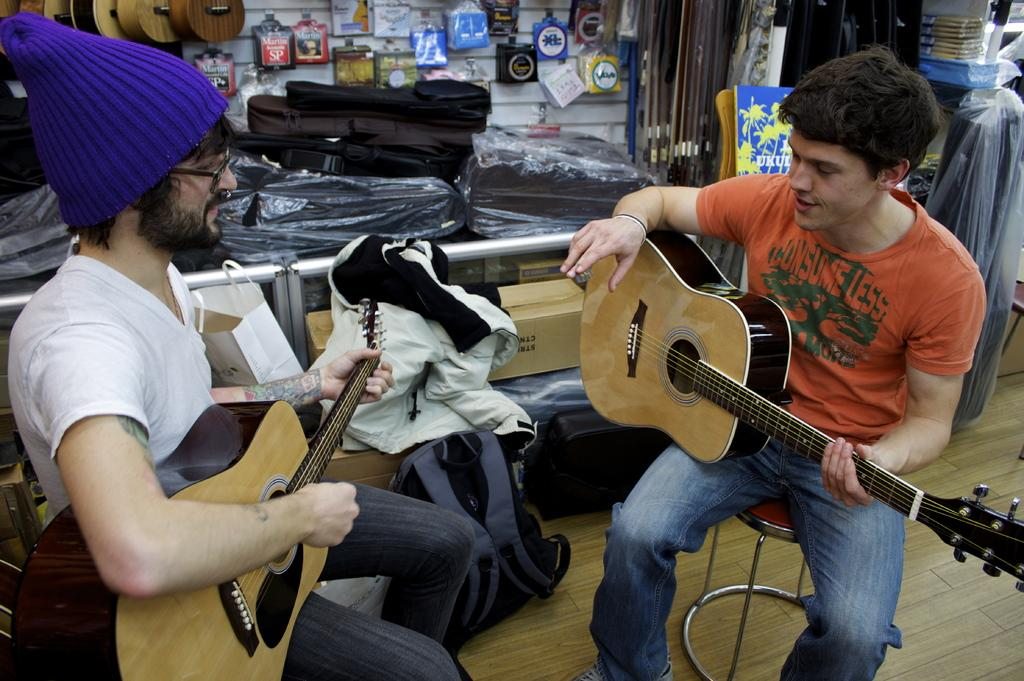How many people are in the image? There are two men in the image. What are the men doing in the image? The men are sitting on stools and playing guitars. Can you describe the objects behind the men? There are bags placed in the background behind a railing. Reasoning: Let'g: Let's think step by step in order to produce the conversation. We start by identifying the main subjects in the image, which are the two men. Then, we describe what the men are doing, which is sitting on stools and playing guitars. Finally, we mention the objects in the background, which are bags placed behind a railing. Absurd Question/Answer: What is the weather like in the image? The provided facts do not mention the weather, so we cannot determine the weather from the image. Can you tell me which of the men is the most accomplished achiever? The provided facts do not mention any achievements or comparisons between the two men, so we cannot determine which one is the most accomplished achiever. What type of sea creature can be seen swimming in the image? There is no sea creature present in the image; it features two men playing guitars on stools. 